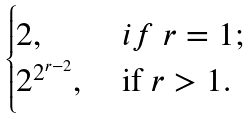Convert formula to latex. <formula><loc_0><loc_0><loc_500><loc_500>\begin{cases} 2 , \ & i f \ r = 1 ; \\ 2 ^ { 2 ^ { r - 2 } } , \ & \text {if} \ r > 1 . \end{cases}</formula> 